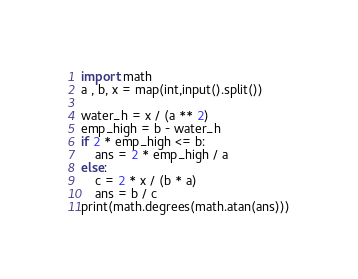Convert code to text. <code><loc_0><loc_0><loc_500><loc_500><_Python_>import math
a , b, x = map(int,input().split())

water_h = x / (a ** 2)
emp_high = b - water_h
if 2 * emp_high <= b:
    ans = 2 * emp_high / a
else:
    c = 2 * x / (b * a)
    ans = b / c
print(math.degrees(math.atan(ans)))</code> 